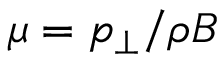<formula> <loc_0><loc_0><loc_500><loc_500>\mu = p _ { \perp } / \rho B</formula> 